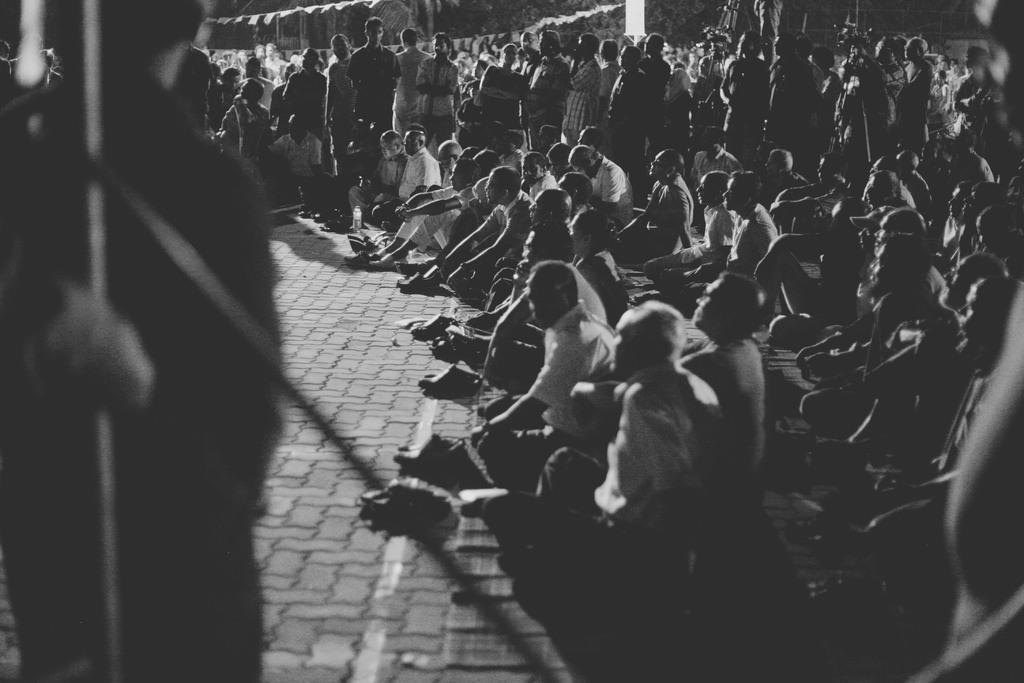Can you describe this image briefly? This is a black and white image. In this image I can see many people are sitting on the floor and few are standing and looking at the left side. On the left side, I can see a person standing and also there is a metal rod. 